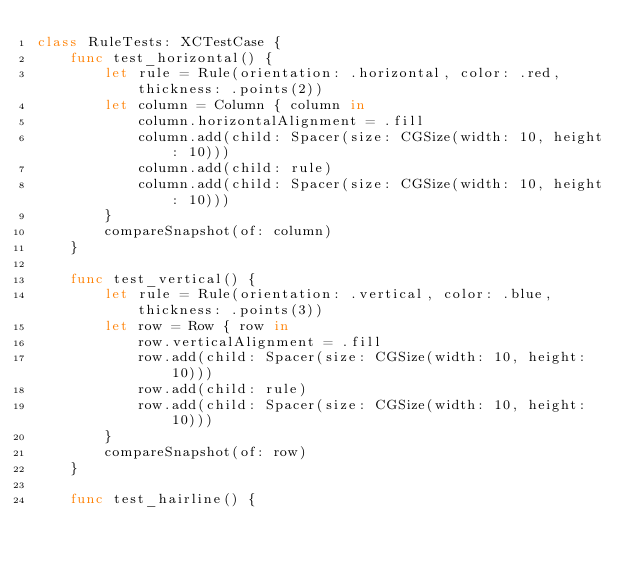<code> <loc_0><loc_0><loc_500><loc_500><_Swift_>class RuleTests: XCTestCase {
    func test_horizontal() {
        let rule = Rule(orientation: .horizontal, color: .red, thickness: .points(2))
        let column = Column { column in
            column.horizontalAlignment = .fill
            column.add(child: Spacer(size: CGSize(width: 10, height: 10)))
            column.add(child: rule)
            column.add(child: Spacer(size: CGSize(width: 10, height: 10)))
        }
        compareSnapshot(of: column)
    }

    func test_vertical() {
        let rule = Rule(orientation: .vertical, color: .blue, thickness: .points(3))
        let row = Row { row in
            row.verticalAlignment = .fill
            row.add(child: Spacer(size: CGSize(width: 10, height: 10)))
            row.add(child: rule)
            row.add(child: Spacer(size: CGSize(width: 10, height: 10)))
        }
        compareSnapshot(of: row)
    }

    func test_hairline() {</code> 